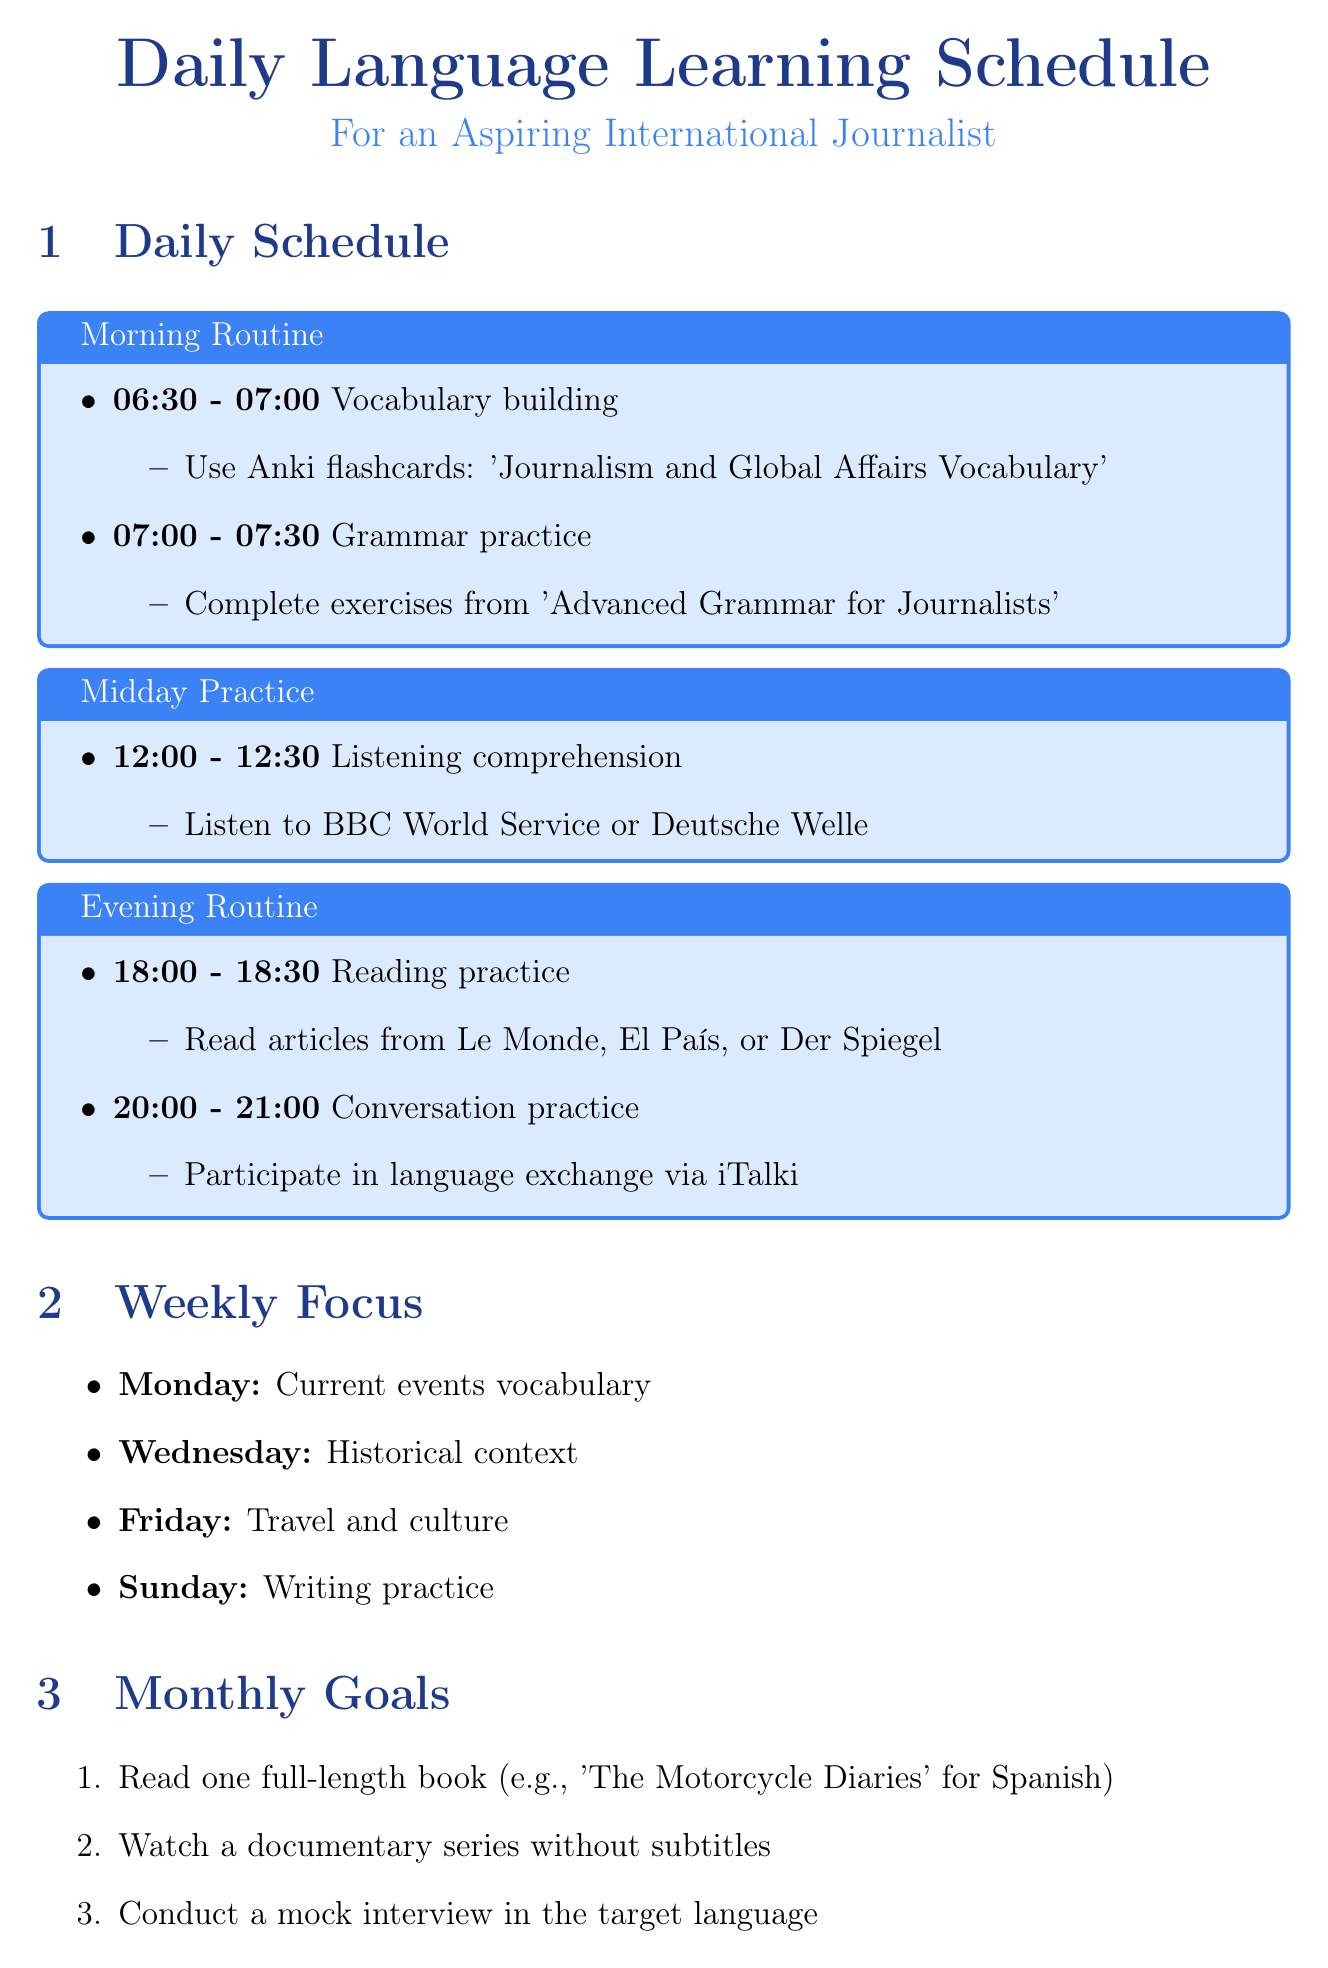What is the time slot for vocabulary building? The vocabulary building activity takes place in the morning from 06:30 to 07:00.
Answer: 06:30 - 07:00 What resource is used for grammar practice? Grammar practice is done using the workbook titled 'Advanced Grammar for Journalists'.
Answer: Advanced Grammar for Journalists What day is focused on current events vocabulary? Current events vocabulary is the focus for Monday in the weekly activities.
Answer: Monday What is one goal for the month related to reading? One of the monthly goals is to read a full-length book in the target language.
Answer: Read one full-length book What app is recommended for learning idiomatic expressions? The app recommended for learning idiomatic expressions is Memrise.
Answer: Memrise What is the main technique suggested for cultural immersion? The main cultural immersion technique suggested is to attend cultural events related to the target language countries.
Answer: Attend cultural events What activity takes place between 20:00 and 21:00? The activity during this time slot is conversation practice.
Answer: Conversation practice How long are the daily sessions in Duolingo? The daily sessions in Duolingo are 15 minutes long.
Answer: 15 minutes What is the focus of the writing practice on Sunday? The focus for writing practice on Sunday is to compose a short article.
Answer: Compose a short article What is the main purpose of using Anki flashcards? The main purpose of using Anki flashcards is for vocabulary building.
Answer: Vocabulary building 